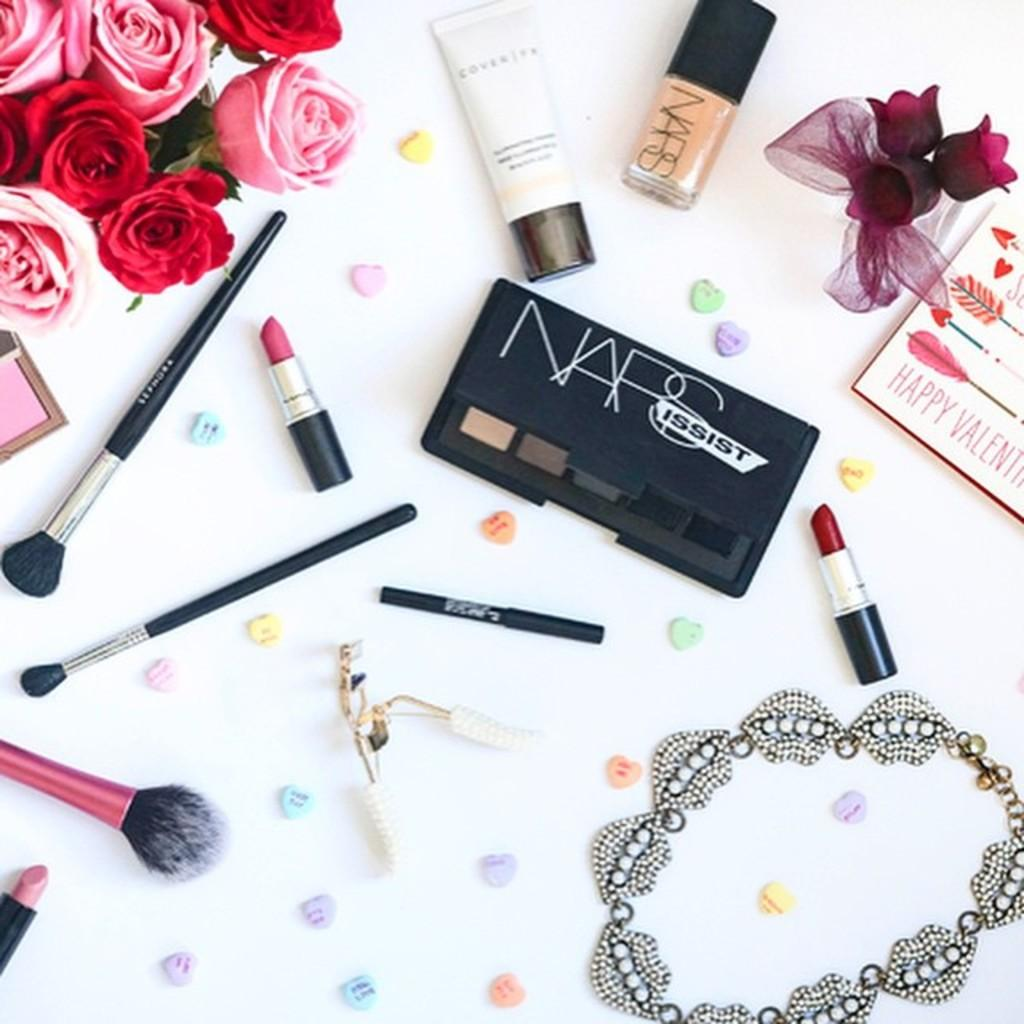<image>
Give a short and clear explanation of the subsequent image. Here we have a marketing picture for NARS Cosmetics. 